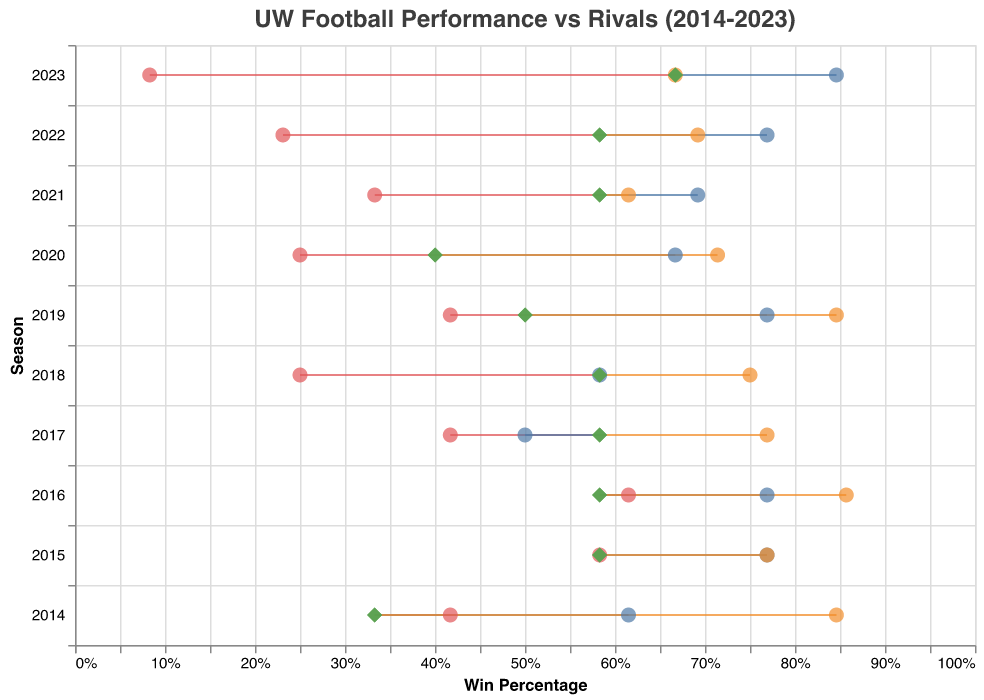What is the win percentage of the UW Football Team in the 2023 season? Look at the "UW Win Percentage" value corresponding to the year 2023 in the plot.
Answer: 0.667 Which rival team had the lowest win percentage in the 2023 season? Compare the "Win Percentage" points of "Colorado State," "Air Force," and "Boise State" in 2023. Colorado State has the lowest win percentage.
Answer: Colorado State In which season did the UW Football Team have the same win percentage as Colorado State? Look for the seasons where the "UW Win Percentage" and "Win Percentage" (of Colorado State) points overlap. This happens in 2015.
Answer: 2015 How does the UW Football Team's win percentage compare to Boise State's win percentage in the 2016 season? Check the "UW Win Percentage" and the "Win Percentage" of Boise State in 2016. UW has a lower win percentage (0.583 vs 0.857).
Answer: UW has a lower win percentage During which season did Air Force have the highest win percentage, and what was the percentage? Identify the highest "Win Percentage" point for Air Force over the seasons. The highest is in 2023 with a win percentage of 0.846.
Answer: 2023, 0.846 What trend can be observed in the win percentage of Colorado State over the seasons? Observe the placement of Colorado State's "Win Percentage" points over time. There's a decreasing trend from 2014 to 2023.
Answer: Decreasing trend For which seasons did the UW Football Team have a higher win percentage than Air Force? Compare "UW Win Percentage" and "Win Percentage" for Air Force over each season. UW has higher percentages in 2017, 2018, 2021, and 2022.
Answer: 2017, 2018, 2021, 2022 What is the average win percentage of the UW Football Team across all seasons shown? Sum the "UW Win Percentage" for all seasons and divide by the number of seasons. (0.333+0.583+0.583+0.583+0.583+0.500+0.400+0.583+0.583+0.667)/10 = 5.397/10 = 0.54
Answer: 0.54 In which seasons did the win percentage of all three rival teams exceed that of the UW Football Team? Check each season to find years where "Win Percentage" of Colorado State, Air Force, and Boise State all exceed "UW Win Percentage." This occurs in 2014, 2016, and 2019.
Answer: 2014, 2016, 2019 